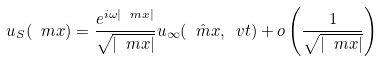<formula> <loc_0><loc_0><loc_500><loc_500>u _ { S } ( \ m x ) = \frac { e ^ { i \omega | \ m x | } } { \sqrt { | \ m x | } } u _ { \infty } ( \hat { \ m x } , \ v t ) + o \left ( \frac { 1 } { \sqrt { | \ m x | } } \right )</formula> 